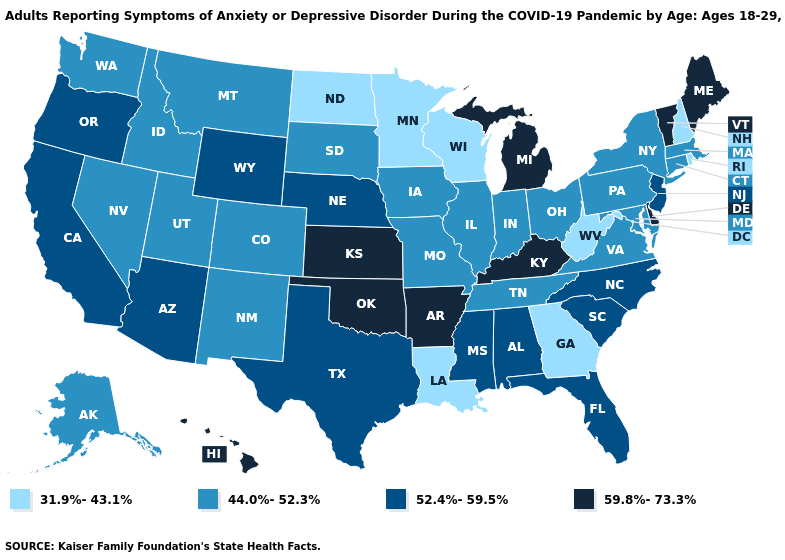What is the value of Alabama?
Short answer required. 52.4%-59.5%. Does the map have missing data?
Answer briefly. No. What is the value of Pennsylvania?
Concise answer only. 44.0%-52.3%. Name the states that have a value in the range 31.9%-43.1%?
Be succinct. Georgia, Louisiana, Minnesota, New Hampshire, North Dakota, Rhode Island, West Virginia, Wisconsin. Is the legend a continuous bar?
Quick response, please. No. Name the states that have a value in the range 44.0%-52.3%?
Concise answer only. Alaska, Colorado, Connecticut, Idaho, Illinois, Indiana, Iowa, Maryland, Massachusetts, Missouri, Montana, Nevada, New Mexico, New York, Ohio, Pennsylvania, South Dakota, Tennessee, Utah, Virginia, Washington. Does North Carolina have a higher value than Kansas?
Keep it brief. No. What is the value of California?
Write a very short answer. 52.4%-59.5%. Among the states that border Georgia , does Alabama have the lowest value?
Answer briefly. No. What is the value of Iowa?
Concise answer only. 44.0%-52.3%. Does Oklahoma have the highest value in the USA?
Be succinct. Yes. Among the states that border New York , which have the lowest value?
Quick response, please. Connecticut, Massachusetts, Pennsylvania. Name the states that have a value in the range 59.8%-73.3%?
Be succinct. Arkansas, Delaware, Hawaii, Kansas, Kentucky, Maine, Michigan, Oklahoma, Vermont. Is the legend a continuous bar?
Write a very short answer. No. 